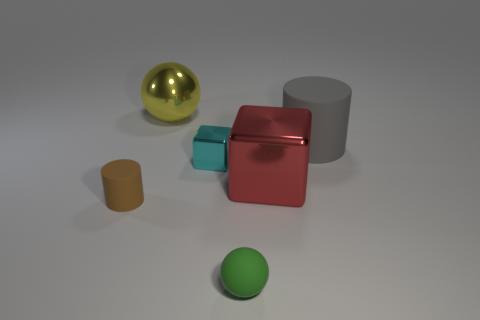Add 1 large matte cubes. How many objects exist? 7 Subtract all cylinders. How many objects are left? 4 Add 6 brown cylinders. How many brown cylinders exist? 7 Subtract 0 green blocks. How many objects are left? 6 Subtract all tiny green cylinders. Subtract all metal spheres. How many objects are left? 5 Add 6 big shiny balls. How many big shiny balls are left? 7 